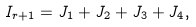<formula> <loc_0><loc_0><loc_500><loc_500>I _ { r + 1 } = J _ { 1 } + J _ { 2 } + J _ { 3 } + J _ { 4 } ,</formula> 